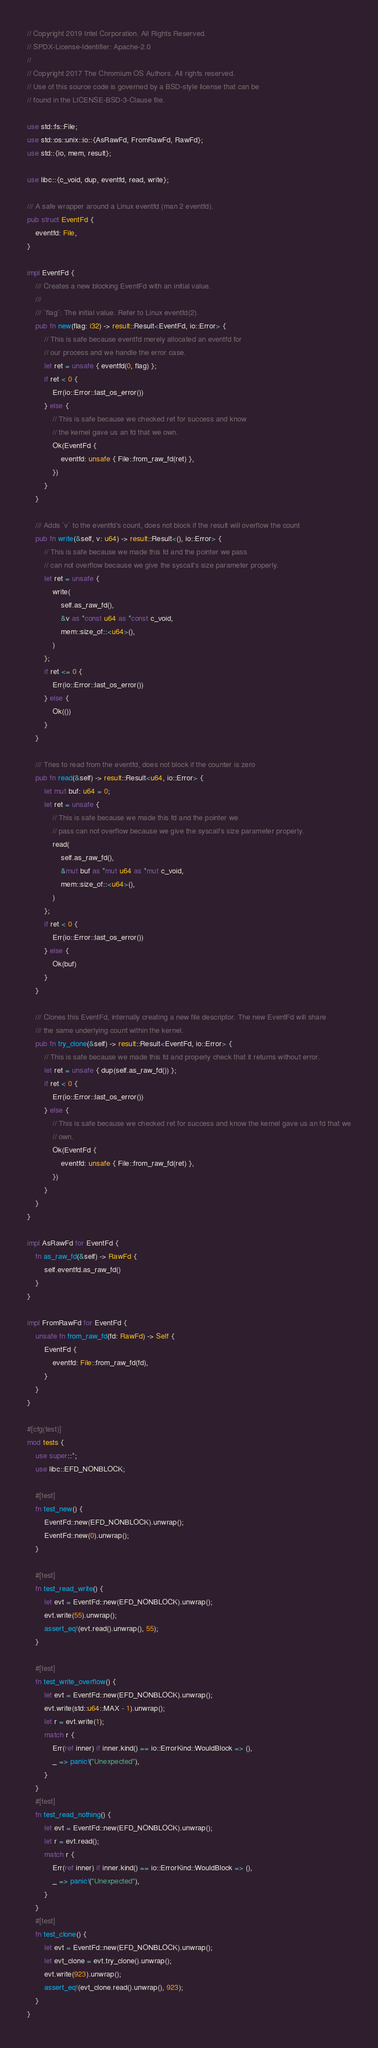<code> <loc_0><loc_0><loc_500><loc_500><_Rust_>// Copyright 2019 Intel Corporation. All Rights Reserved.
// SPDX-License-Identifier: Apache-2.0
//
// Copyright 2017 The Chromium OS Authors. All rights reserved.
// Use of this source code is governed by a BSD-style license that can be
// found in the LICENSE-BSD-3-Clause file.

use std::fs::File;
use std::os::unix::io::{AsRawFd, FromRawFd, RawFd};
use std::{io, mem, result};

use libc::{c_void, dup, eventfd, read, write};

/// A safe wrapper around a Linux eventfd (man 2 eventfd).
pub struct EventFd {
    eventfd: File,
}

impl EventFd {
    /// Creates a new blocking EventFd with an initial value.
    ///
    /// `flag`: The initial value. Refer to Linux eventfd(2).
    pub fn new(flag: i32) -> result::Result<EventFd, io::Error> {
        // This is safe because eventfd merely allocated an eventfd for
        // our process and we handle the error case.
        let ret = unsafe { eventfd(0, flag) };
        if ret < 0 {
            Err(io::Error::last_os_error())
        } else {
            // This is safe because we checked ret for success and know
            // the kernel gave us an fd that we own.
            Ok(EventFd {
                eventfd: unsafe { File::from_raw_fd(ret) },
            })
        }
    }

    /// Adds `v` to the eventfd's count, does not block if the result will overflow the count
    pub fn write(&self, v: u64) -> result::Result<(), io::Error> {
        // This is safe because we made this fd and the pointer we pass
        // can not overflow because we give the syscall's size parameter properly.
        let ret = unsafe {
            write(
                self.as_raw_fd(),
                &v as *const u64 as *const c_void,
                mem::size_of::<u64>(),
            )
        };
        if ret <= 0 {
            Err(io::Error::last_os_error())
        } else {
            Ok(())
        }
    }

    /// Tries to read from the eventfd, does not block if the counter is zero
    pub fn read(&self) -> result::Result<u64, io::Error> {
        let mut buf: u64 = 0;
        let ret = unsafe {
            // This is safe because we made this fd and the pointer we
            // pass can not overflow because we give the syscall's size parameter properly.
            read(
                self.as_raw_fd(),
                &mut buf as *mut u64 as *mut c_void,
                mem::size_of::<u64>(),
            )
        };
        if ret < 0 {
            Err(io::Error::last_os_error())
        } else {
            Ok(buf)
        }
    }

    /// Clones this EventFd, internally creating a new file descriptor. The new EventFd will share
    /// the same underlying count within the kernel.
    pub fn try_clone(&self) -> result::Result<EventFd, io::Error> {
        // This is safe because we made this fd and properly check that it returns without error.
        let ret = unsafe { dup(self.as_raw_fd()) };
        if ret < 0 {
            Err(io::Error::last_os_error())
        } else {
            // This is safe because we checked ret for success and know the kernel gave us an fd that we
            // own.
            Ok(EventFd {
                eventfd: unsafe { File::from_raw_fd(ret) },
            })
        }
    }
}

impl AsRawFd for EventFd {
    fn as_raw_fd(&self) -> RawFd {
        self.eventfd.as_raw_fd()
    }
}

impl FromRawFd for EventFd {
    unsafe fn from_raw_fd(fd: RawFd) -> Self {
        EventFd {
            eventfd: File::from_raw_fd(fd),
        }
    }
}

#[cfg(test)]
mod tests {
    use super::*;
    use libc::EFD_NONBLOCK;

    #[test]
    fn test_new() {
        EventFd::new(EFD_NONBLOCK).unwrap();
        EventFd::new(0).unwrap();
    }

    #[test]
    fn test_read_write() {
        let evt = EventFd::new(EFD_NONBLOCK).unwrap();
        evt.write(55).unwrap();
        assert_eq!(evt.read().unwrap(), 55);
    }

    #[test]
    fn test_write_overflow() {
        let evt = EventFd::new(EFD_NONBLOCK).unwrap();
        evt.write(std::u64::MAX - 1).unwrap();
        let r = evt.write(1);
        match r {
            Err(ref inner) if inner.kind() == io::ErrorKind::WouldBlock => (),
            _ => panic!("Unexpected"),
        }
    }
    #[test]
    fn test_read_nothing() {
        let evt = EventFd::new(EFD_NONBLOCK).unwrap();
        let r = evt.read();
        match r {
            Err(ref inner) if inner.kind() == io::ErrorKind::WouldBlock => (),
            _ => panic!("Unexpected"),
        }
    }
    #[test]
    fn test_clone() {
        let evt = EventFd::new(EFD_NONBLOCK).unwrap();
        let evt_clone = evt.try_clone().unwrap();
        evt.write(923).unwrap();
        assert_eq!(evt_clone.read().unwrap(), 923);
    }
}
</code> 